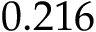Convert formula to latex. <formula><loc_0><loc_0><loc_500><loc_500>0 . 2 1 6</formula> 